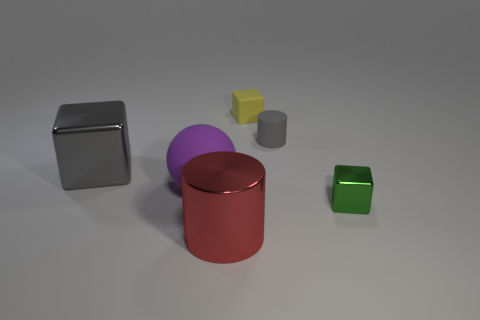Add 1 tiny gray cylinders. How many objects exist? 7 Subtract all balls. How many objects are left? 5 Subtract 1 red cylinders. How many objects are left? 5 Subtract all purple rubber objects. Subtract all small brown rubber spheres. How many objects are left? 5 Add 2 small gray objects. How many small gray objects are left? 3 Add 2 gray rubber things. How many gray rubber things exist? 3 